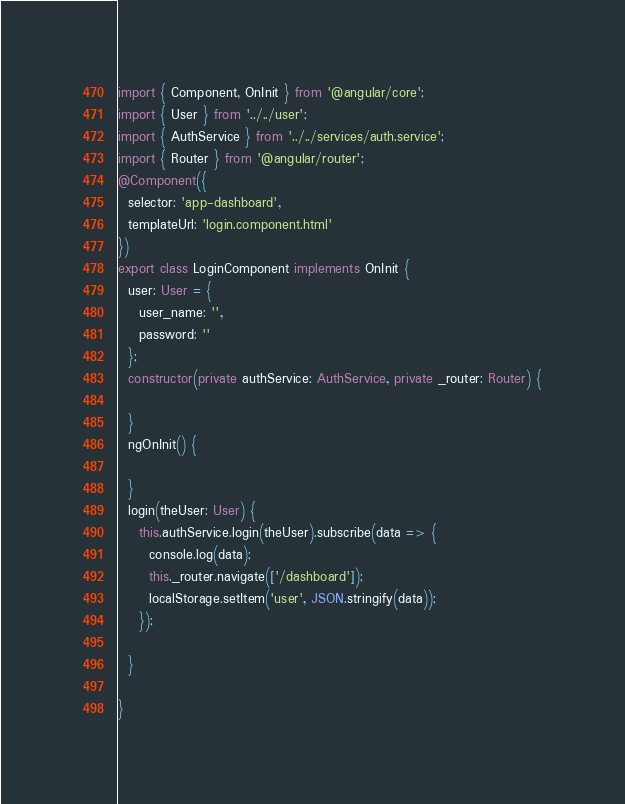<code> <loc_0><loc_0><loc_500><loc_500><_TypeScript_>import { Component, OnInit } from '@angular/core';
import { User } from '../../user';
import { AuthService } from '../../services/auth.service';
import { Router } from '@angular/router';
@Component({
  selector: 'app-dashboard',
  templateUrl: 'login.component.html'
})
export class LoginComponent implements OnInit {
  user: User = {
    user_name: '',
    password: ''
  };
  constructor(private authService: AuthService, private _router: Router) {

  }
  ngOnInit() {

  }
  login(theUser: User) {
    this.authService.login(theUser).subscribe(data => {
      console.log(data);
      this._router.navigate(['/dashboard']);
      localStorage.setItem('user', JSON.stringify(data));
    });

  }

}
</code> 